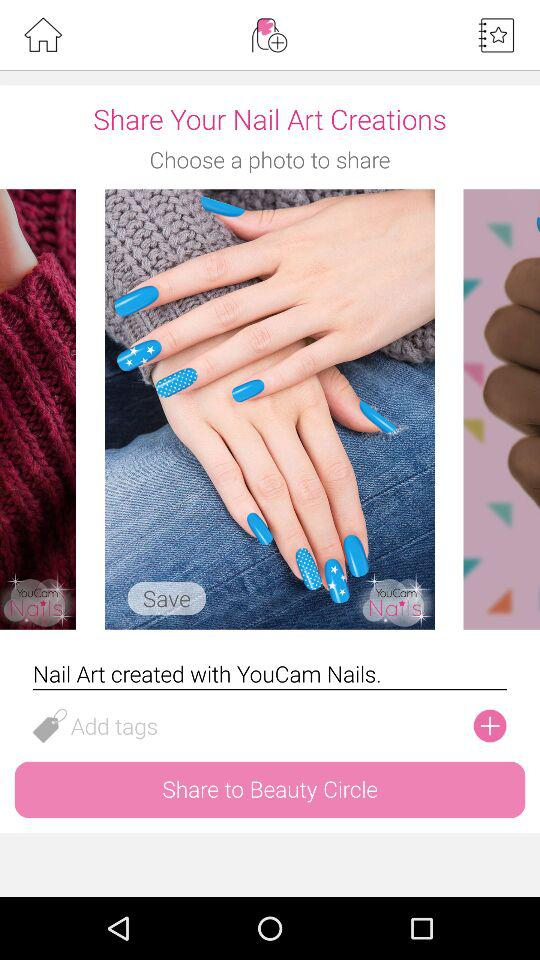What's the name of the filter used for nail art creation? The name of the filter is "YouCam Nails". 